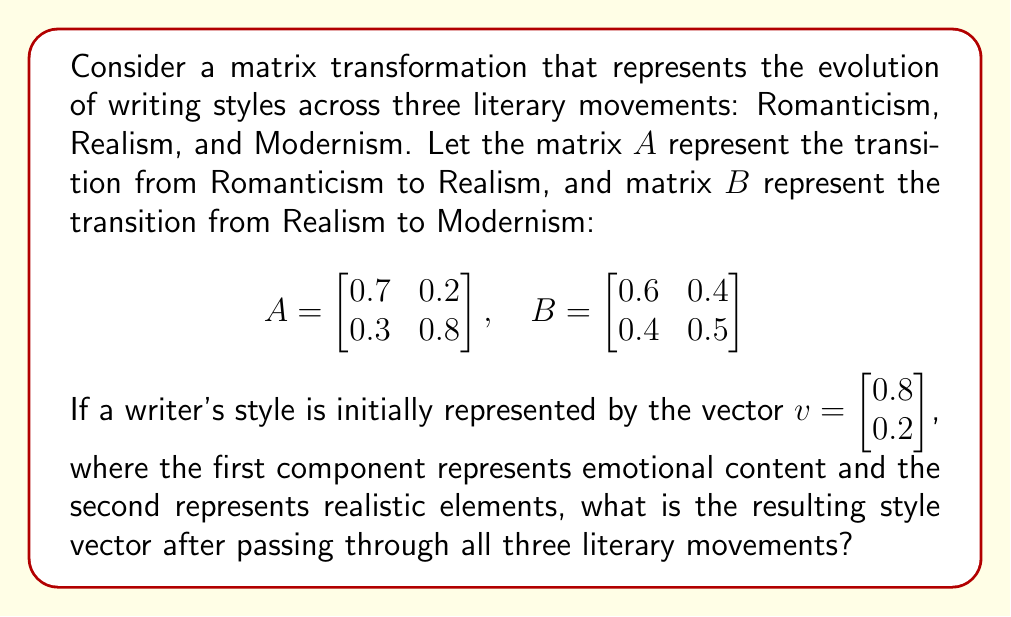Provide a solution to this math problem. To solve this problem, we need to apply the matrix transformations in sequence:

1. First, we apply matrix $A$ to transform from Romanticism to Realism:
   $$v_1 = A \cdot v = \begin{bmatrix}
   0.7 & 0.2 \\
   0.3 & 0.8
   \end{bmatrix} \cdot \begin{bmatrix}
   0.8 \\
   0.2
   \end{bmatrix}$$

   $$v_1 = \begin{bmatrix}
   (0.7 \cdot 0.8) + (0.2 \cdot 0.2) \\
   (0.3 \cdot 0.8) + (0.8 \cdot 0.2)
   \end{bmatrix} = \begin{bmatrix}
   0.6 \\
   0.4
   \end{bmatrix}$$

2. Next, we apply matrix $B$ to transform from Realism to Modernism:
   $$v_2 = B \cdot v_1 = \begin{bmatrix}
   0.6 & 0.4 \\
   0.4 & 0.5
   \end{bmatrix} \cdot \begin{bmatrix}
   0.6 \\
   0.4
   \end{bmatrix}$$

   $$v_2 = \begin{bmatrix}
   (0.6 \cdot 0.6) + (0.4 \cdot 0.4) \\
   (0.4 \cdot 0.6) + (0.5 \cdot 0.4)
   \end{bmatrix} = \begin{bmatrix}
   0.52 \\
   0.44
   \end{bmatrix}$$

3. The resulting style vector $v_2$ represents the writer's style after passing through all three literary movements.
Answer: $\begin{bmatrix} 0.52 \\ 0.44 \end{bmatrix}$ 